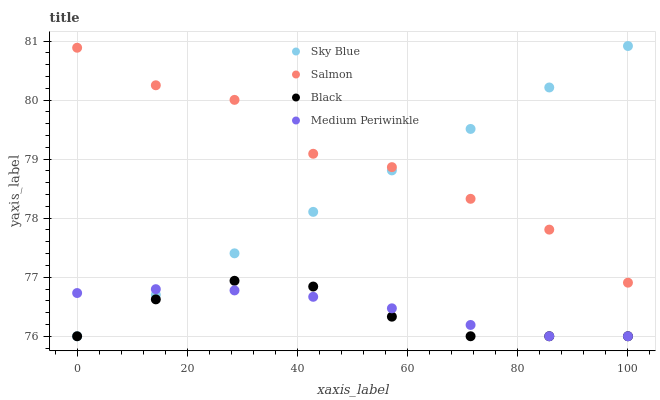Does Black have the minimum area under the curve?
Answer yes or no. Yes. Does Salmon have the maximum area under the curve?
Answer yes or no. Yes. Does Salmon have the minimum area under the curve?
Answer yes or no. No. Does Black have the maximum area under the curve?
Answer yes or no. No. Is Sky Blue the smoothest?
Answer yes or no. Yes. Is Salmon the roughest?
Answer yes or no. Yes. Is Black the smoothest?
Answer yes or no. No. Is Black the roughest?
Answer yes or no. No. Does Sky Blue have the lowest value?
Answer yes or no. Yes. Does Salmon have the lowest value?
Answer yes or no. No. Does Sky Blue have the highest value?
Answer yes or no. Yes. Does Salmon have the highest value?
Answer yes or no. No. Is Medium Periwinkle less than Salmon?
Answer yes or no. Yes. Is Salmon greater than Medium Periwinkle?
Answer yes or no. Yes. Does Black intersect Medium Periwinkle?
Answer yes or no. Yes. Is Black less than Medium Periwinkle?
Answer yes or no. No. Is Black greater than Medium Periwinkle?
Answer yes or no. No. Does Medium Periwinkle intersect Salmon?
Answer yes or no. No. 